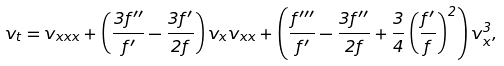<formula> <loc_0><loc_0><loc_500><loc_500>v _ { t } = v _ { x x x } + \left ( \frac { 3 f ^ { \prime \prime } } { f ^ { \prime } } - \frac { 3 f ^ { \prime } } { 2 f } \right ) v _ { x } v _ { x x } + \left ( \frac { f ^ { \prime \prime \prime } } { f ^ { \prime } } - \frac { 3 f ^ { \prime \prime } } { 2 f } + \frac { 3 } { 4 } \left ( \frac { f ^ { \prime } } { f } \right ) ^ { 2 } \right ) v _ { x } ^ { 3 } ,</formula> 